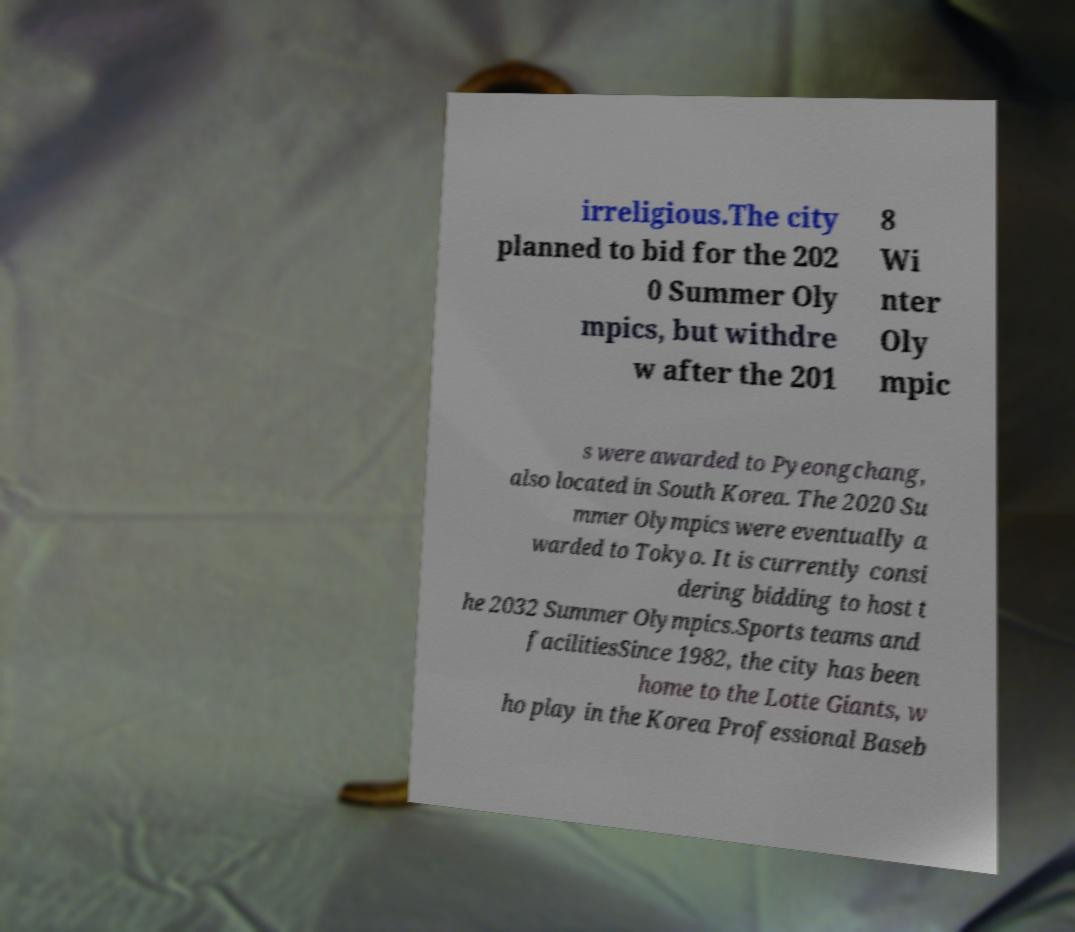I need the written content from this picture converted into text. Can you do that? irreligious.The city planned to bid for the 202 0 Summer Oly mpics, but withdre w after the 201 8 Wi nter Oly mpic s were awarded to Pyeongchang, also located in South Korea. The 2020 Su mmer Olympics were eventually a warded to Tokyo. It is currently consi dering bidding to host t he 2032 Summer Olympics.Sports teams and facilitiesSince 1982, the city has been home to the Lotte Giants, w ho play in the Korea Professional Baseb 